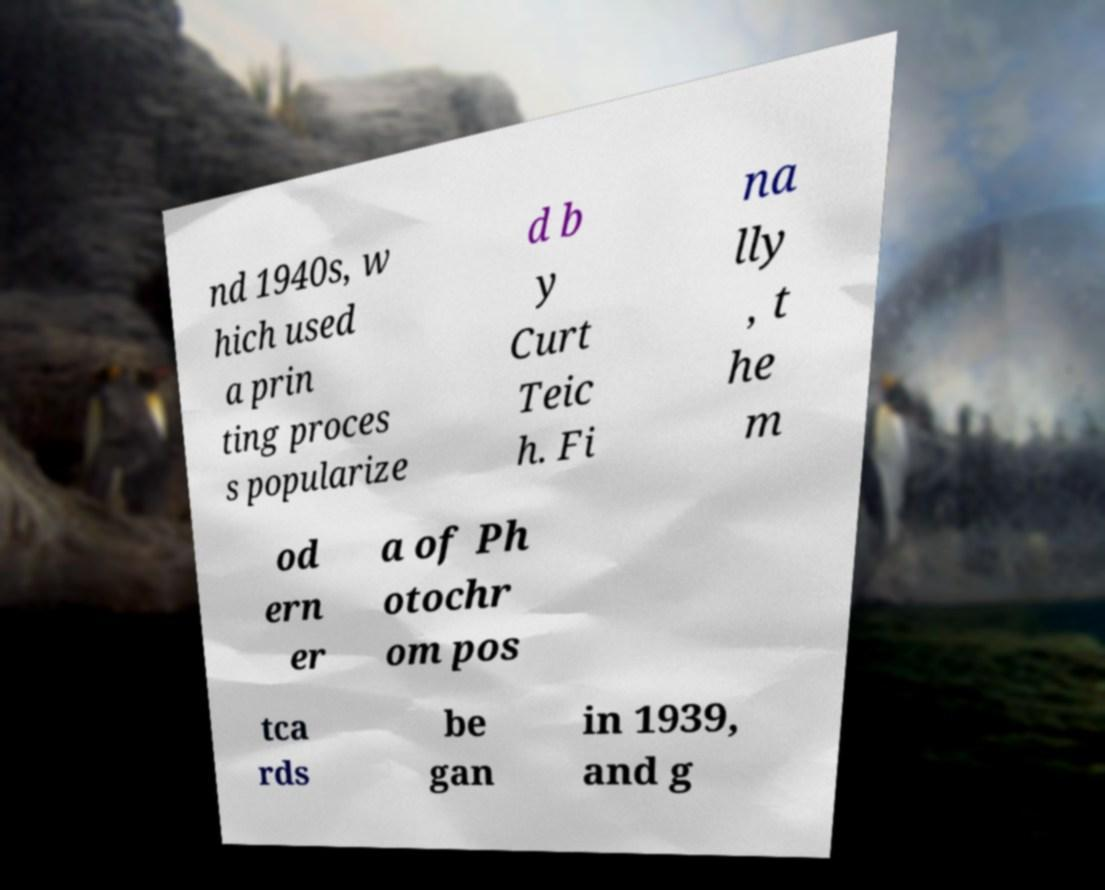There's text embedded in this image that I need extracted. Can you transcribe it verbatim? nd 1940s, w hich used a prin ting proces s popularize d b y Curt Teic h. Fi na lly , t he m od ern er a of Ph otochr om pos tca rds be gan in 1939, and g 